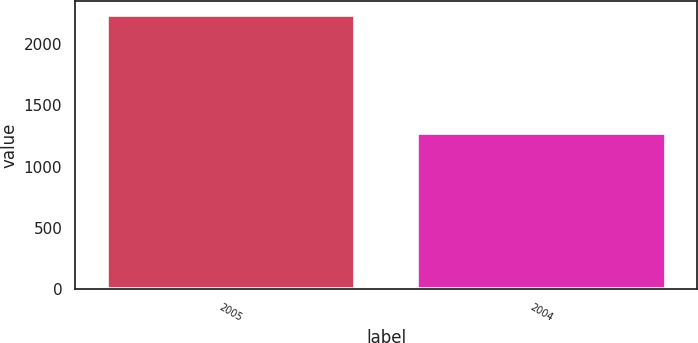Convert chart. <chart><loc_0><loc_0><loc_500><loc_500><bar_chart><fcel>2005<fcel>2004<nl><fcel>2236<fcel>1271<nl></chart> 